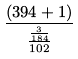Convert formula to latex. <formula><loc_0><loc_0><loc_500><loc_500>\frac { ( 3 9 4 + 1 ) } { \frac { \frac { 3 } { 1 8 4 } } { 1 0 2 } }</formula> 